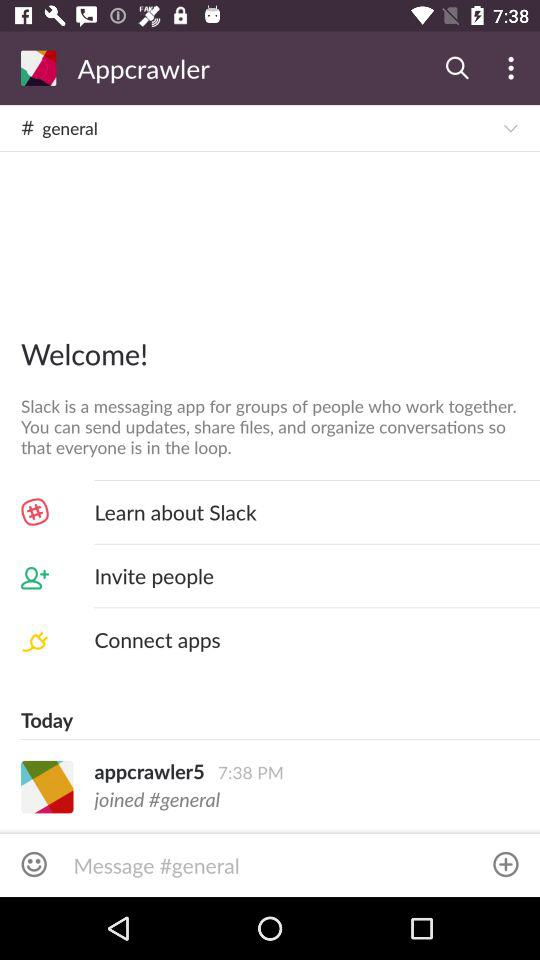What are the features of the "Slack" application? The features are sending updates, sharing files, and organizing conversations so that everyone is in the loop. 